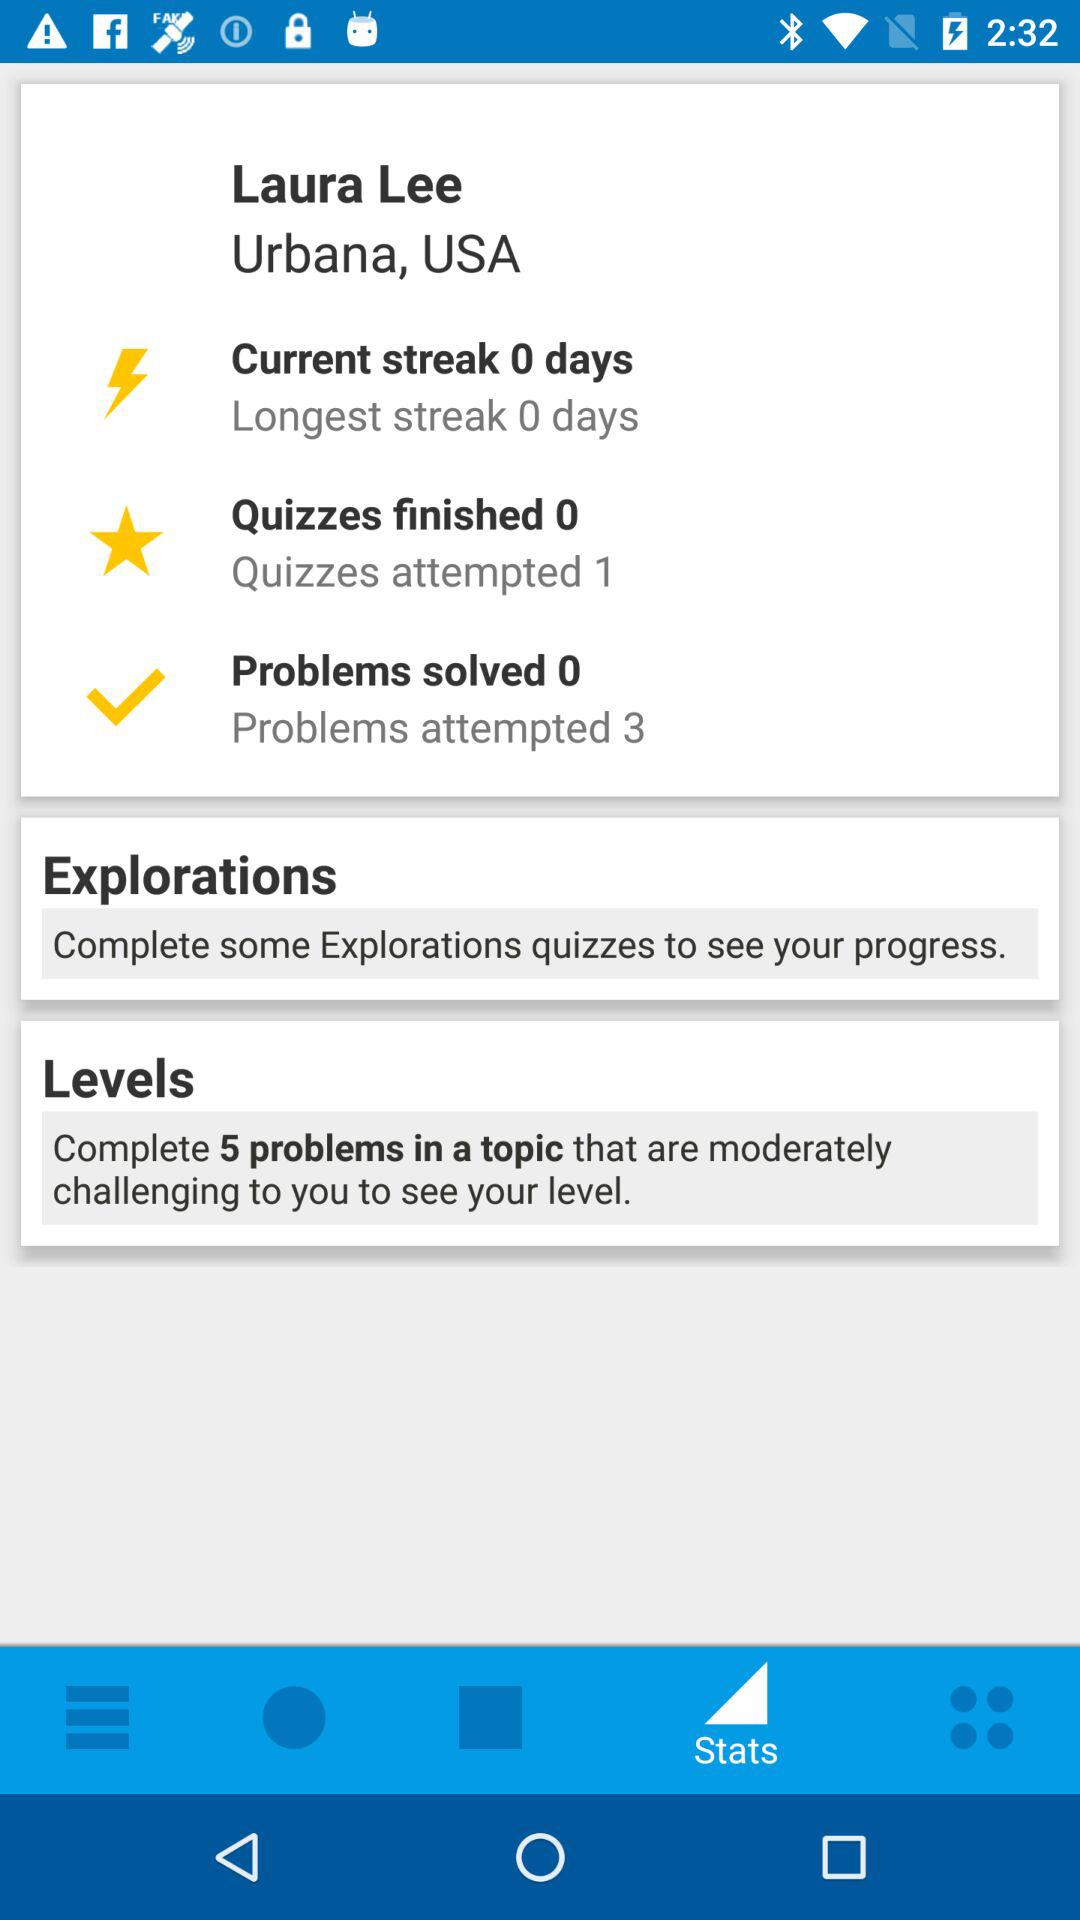How many attempts left to finish quizzes?
When the provided information is insufficient, respond with <no answer>. <no answer> 